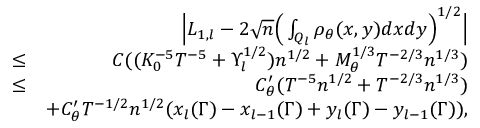<formula> <loc_0><loc_0><loc_500><loc_500>\begin{array} { r l r } & { \left | L _ { 1 , l } - 2 \sqrt { n } \left ( \int _ { Q _ { l } } \rho _ { \theta } ( x , y ) d x d y \right ) ^ { 1 \slash 2 } \right | } \\ & { \leq } & { C ( ( K _ { 0 } ^ { - 5 } T ^ { - 5 } + \Upsilon _ { l } ^ { 1 \slash 2 } ) n ^ { 1 \slash 2 } + M _ { \theta } ^ { 1 \slash 3 } T ^ { - 2 \slash 3 } n ^ { 1 \slash 3 } ) } \\ & { \leq } & { C _ { \theta } ^ { \prime } ( T ^ { - 5 } n ^ { 1 \slash 2 } + T ^ { - 2 \slash 3 } n ^ { 1 \slash 3 } ) } \\ & { + C _ { \theta } ^ { \prime } T ^ { - 1 \slash 2 } n ^ { 1 \slash 2 } ( x _ { l } ( \Gamma ) - x _ { l - 1 } ( \Gamma ) + y _ { l } ( \Gamma ) - y _ { l - 1 } ( \Gamma ) ) , } \end{array}</formula> 